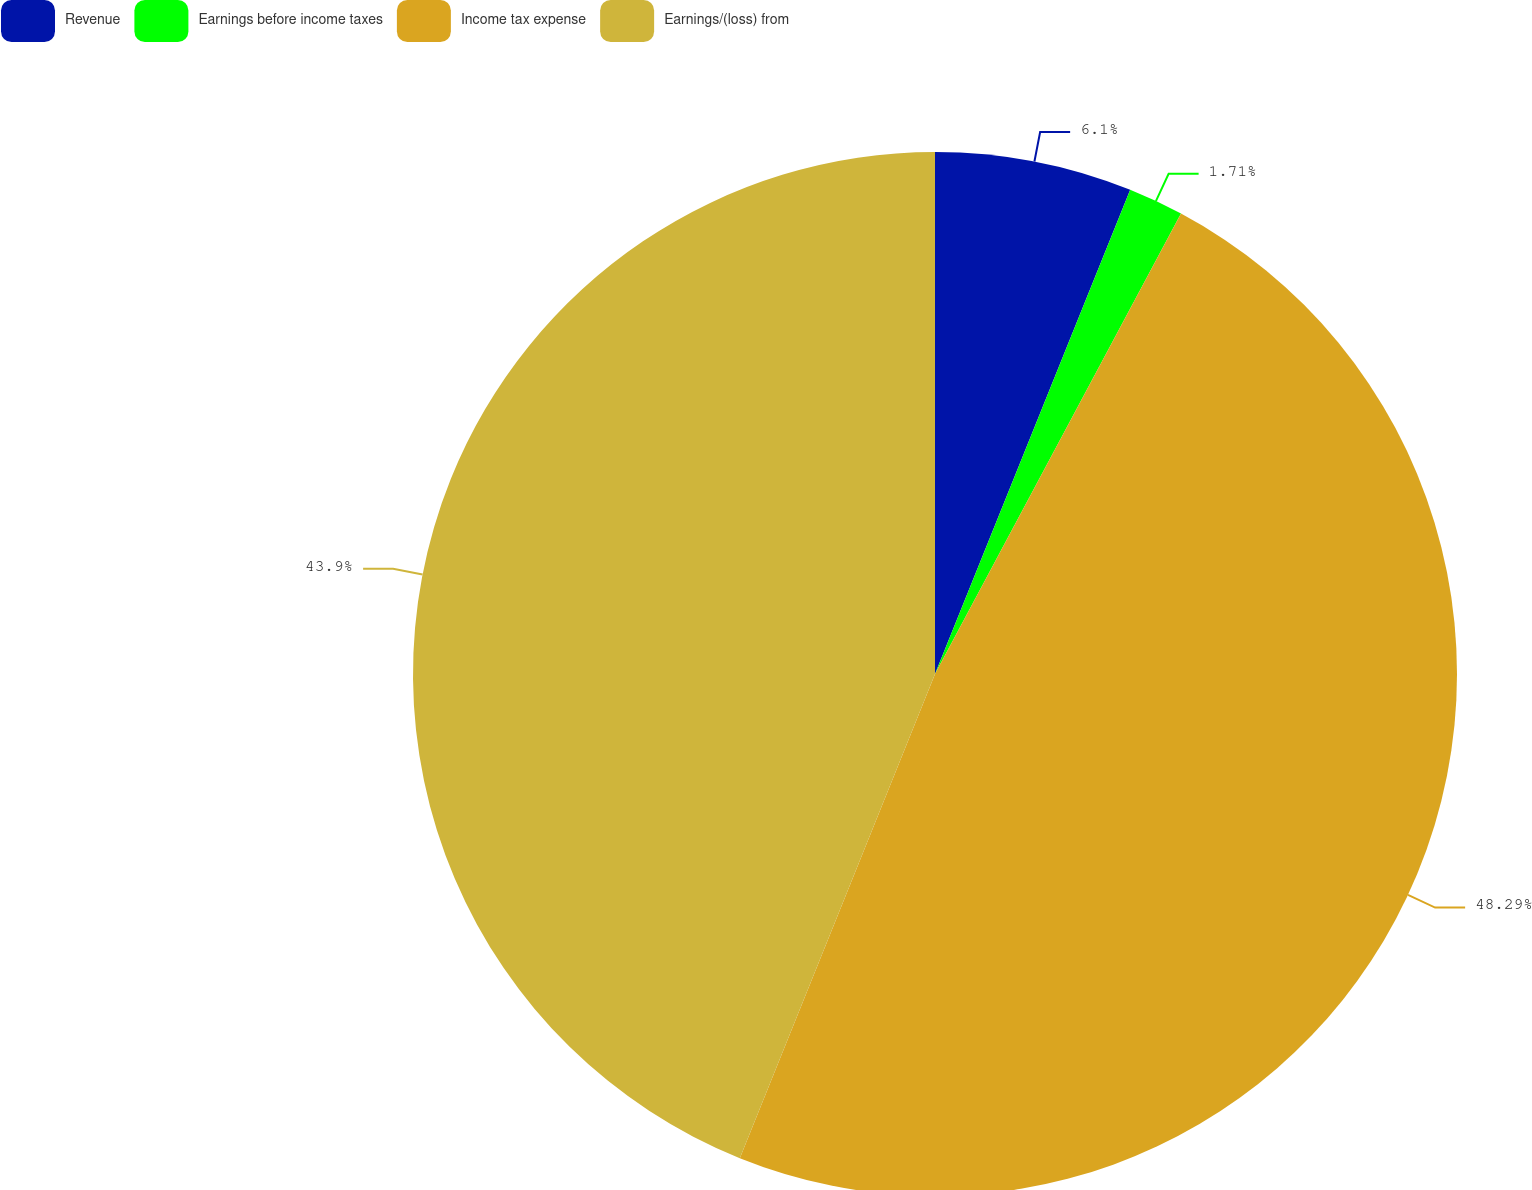Convert chart to OTSL. <chart><loc_0><loc_0><loc_500><loc_500><pie_chart><fcel>Revenue<fcel>Earnings before income taxes<fcel>Income tax expense<fcel>Earnings/(loss) from<nl><fcel>6.1%<fcel>1.71%<fcel>48.29%<fcel>43.9%<nl></chart> 